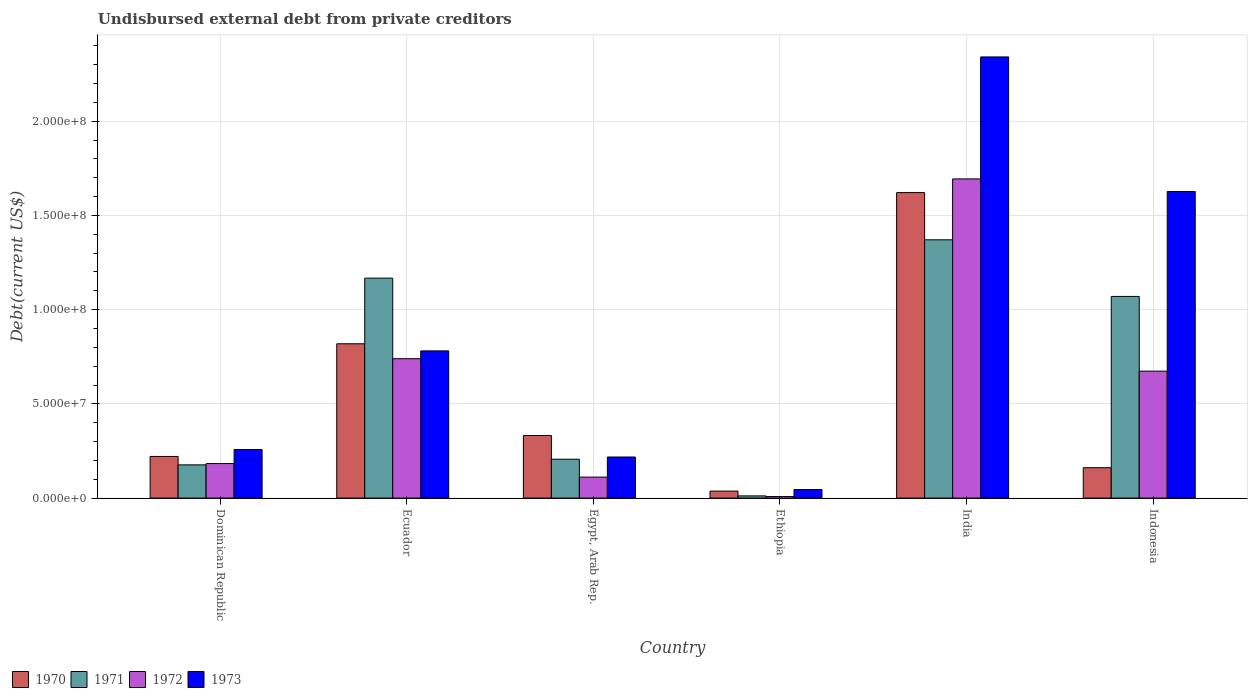What is the label of the 3rd group of bars from the left?
Give a very brief answer. Egypt, Arab Rep. In how many cases, is the number of bars for a given country not equal to the number of legend labels?
Make the answer very short. 0. What is the total debt in 1970 in Ethiopia?
Make the answer very short. 3.70e+06. Across all countries, what is the maximum total debt in 1972?
Offer a terse response. 1.69e+08. Across all countries, what is the minimum total debt in 1973?
Offer a very short reply. 4.57e+06. In which country was the total debt in 1973 maximum?
Offer a very short reply. India. In which country was the total debt in 1970 minimum?
Your response must be concise. Ethiopia. What is the total total debt in 1971 in the graph?
Give a very brief answer. 4.00e+08. What is the difference between the total debt in 1973 in Ecuador and that in Indonesia?
Offer a very short reply. -8.46e+07. What is the difference between the total debt in 1970 in Ecuador and the total debt in 1972 in Dominican Republic?
Provide a succinct answer. 6.36e+07. What is the average total debt in 1973 per country?
Your response must be concise. 8.78e+07. What is the difference between the total debt of/in 1972 and total debt of/in 1971 in Ethiopia?
Ensure brevity in your answer.  -3.45e+05. In how many countries, is the total debt in 1972 greater than 30000000 US$?
Offer a very short reply. 3. What is the ratio of the total debt in 1970 in Egypt, Arab Rep. to that in Ethiopia?
Your answer should be compact. 8.99. Is the total debt in 1973 in Egypt, Arab Rep. less than that in India?
Provide a short and direct response. Yes. Is the difference between the total debt in 1972 in Dominican Republic and Ethiopia greater than the difference between the total debt in 1971 in Dominican Republic and Ethiopia?
Provide a succinct answer. Yes. What is the difference between the highest and the second highest total debt in 1972?
Offer a terse response. 6.60e+06. What is the difference between the highest and the lowest total debt in 1973?
Ensure brevity in your answer.  2.30e+08. Is it the case that in every country, the sum of the total debt in 1970 and total debt in 1973 is greater than the sum of total debt in 1972 and total debt in 1971?
Your answer should be compact. No. What does the 2nd bar from the right in Dominican Republic represents?
Give a very brief answer. 1972. Are all the bars in the graph horizontal?
Provide a short and direct response. No. How many countries are there in the graph?
Ensure brevity in your answer.  6. Are the values on the major ticks of Y-axis written in scientific E-notation?
Offer a very short reply. Yes. How are the legend labels stacked?
Provide a succinct answer. Horizontal. What is the title of the graph?
Keep it short and to the point. Undisbursed external debt from private creditors. Does "1976" appear as one of the legend labels in the graph?
Make the answer very short. No. What is the label or title of the X-axis?
Provide a succinct answer. Country. What is the label or title of the Y-axis?
Provide a short and direct response. Debt(current US$). What is the Debt(current US$) of 1970 in Dominican Republic?
Give a very brief answer. 2.21e+07. What is the Debt(current US$) in 1971 in Dominican Republic?
Keep it short and to the point. 1.76e+07. What is the Debt(current US$) in 1972 in Dominican Republic?
Provide a short and direct response. 1.83e+07. What is the Debt(current US$) of 1973 in Dominican Republic?
Provide a short and direct response. 2.58e+07. What is the Debt(current US$) of 1970 in Ecuador?
Keep it short and to the point. 8.19e+07. What is the Debt(current US$) in 1971 in Ecuador?
Your response must be concise. 1.17e+08. What is the Debt(current US$) in 1972 in Ecuador?
Make the answer very short. 7.40e+07. What is the Debt(current US$) in 1973 in Ecuador?
Provide a short and direct response. 7.81e+07. What is the Debt(current US$) in 1970 in Egypt, Arab Rep.?
Offer a very short reply. 3.32e+07. What is the Debt(current US$) in 1971 in Egypt, Arab Rep.?
Keep it short and to the point. 2.06e+07. What is the Debt(current US$) of 1972 in Egypt, Arab Rep.?
Provide a short and direct response. 1.11e+07. What is the Debt(current US$) in 1973 in Egypt, Arab Rep.?
Your answer should be compact. 2.18e+07. What is the Debt(current US$) of 1970 in Ethiopia?
Offer a terse response. 3.70e+06. What is the Debt(current US$) in 1971 in Ethiopia?
Keep it short and to the point. 1.16e+06. What is the Debt(current US$) in 1972 in Ethiopia?
Keep it short and to the point. 8.20e+05. What is the Debt(current US$) of 1973 in Ethiopia?
Give a very brief answer. 4.57e+06. What is the Debt(current US$) of 1970 in India?
Offer a terse response. 1.62e+08. What is the Debt(current US$) in 1971 in India?
Provide a short and direct response. 1.37e+08. What is the Debt(current US$) in 1972 in India?
Make the answer very short. 1.69e+08. What is the Debt(current US$) of 1973 in India?
Your answer should be very brief. 2.34e+08. What is the Debt(current US$) of 1970 in Indonesia?
Your answer should be compact. 1.61e+07. What is the Debt(current US$) of 1971 in Indonesia?
Give a very brief answer. 1.07e+08. What is the Debt(current US$) of 1972 in Indonesia?
Your answer should be very brief. 6.74e+07. What is the Debt(current US$) in 1973 in Indonesia?
Provide a short and direct response. 1.63e+08. Across all countries, what is the maximum Debt(current US$) of 1970?
Your answer should be compact. 1.62e+08. Across all countries, what is the maximum Debt(current US$) in 1971?
Offer a very short reply. 1.37e+08. Across all countries, what is the maximum Debt(current US$) in 1972?
Make the answer very short. 1.69e+08. Across all countries, what is the maximum Debt(current US$) of 1973?
Offer a very short reply. 2.34e+08. Across all countries, what is the minimum Debt(current US$) in 1970?
Offer a very short reply. 3.70e+06. Across all countries, what is the minimum Debt(current US$) of 1971?
Your answer should be very brief. 1.16e+06. Across all countries, what is the minimum Debt(current US$) in 1972?
Your answer should be very brief. 8.20e+05. Across all countries, what is the minimum Debt(current US$) in 1973?
Give a very brief answer. 4.57e+06. What is the total Debt(current US$) of 1970 in the graph?
Offer a terse response. 3.19e+08. What is the total Debt(current US$) in 1971 in the graph?
Offer a terse response. 4.00e+08. What is the total Debt(current US$) in 1972 in the graph?
Your answer should be compact. 3.41e+08. What is the total Debt(current US$) of 1973 in the graph?
Your answer should be very brief. 5.27e+08. What is the difference between the Debt(current US$) of 1970 in Dominican Republic and that in Ecuador?
Provide a short and direct response. -5.98e+07. What is the difference between the Debt(current US$) of 1971 in Dominican Republic and that in Ecuador?
Ensure brevity in your answer.  -9.91e+07. What is the difference between the Debt(current US$) of 1972 in Dominican Republic and that in Ecuador?
Your answer should be compact. -5.57e+07. What is the difference between the Debt(current US$) of 1973 in Dominican Republic and that in Ecuador?
Your answer should be very brief. -5.23e+07. What is the difference between the Debt(current US$) of 1970 in Dominican Republic and that in Egypt, Arab Rep.?
Provide a succinct answer. -1.11e+07. What is the difference between the Debt(current US$) in 1971 in Dominican Republic and that in Egypt, Arab Rep.?
Your response must be concise. -3.00e+06. What is the difference between the Debt(current US$) of 1972 in Dominican Republic and that in Egypt, Arab Rep.?
Your response must be concise. 7.19e+06. What is the difference between the Debt(current US$) in 1973 in Dominican Republic and that in Egypt, Arab Rep.?
Your answer should be very brief. 3.97e+06. What is the difference between the Debt(current US$) in 1970 in Dominican Republic and that in Ethiopia?
Offer a terse response. 1.84e+07. What is the difference between the Debt(current US$) of 1971 in Dominican Republic and that in Ethiopia?
Make the answer very short. 1.65e+07. What is the difference between the Debt(current US$) in 1972 in Dominican Republic and that in Ethiopia?
Give a very brief answer. 1.75e+07. What is the difference between the Debt(current US$) of 1973 in Dominican Republic and that in Ethiopia?
Your answer should be compact. 2.12e+07. What is the difference between the Debt(current US$) of 1970 in Dominican Republic and that in India?
Your response must be concise. -1.40e+08. What is the difference between the Debt(current US$) of 1971 in Dominican Republic and that in India?
Offer a terse response. -1.19e+08. What is the difference between the Debt(current US$) of 1972 in Dominican Republic and that in India?
Offer a very short reply. -1.51e+08. What is the difference between the Debt(current US$) in 1973 in Dominican Republic and that in India?
Provide a succinct answer. -2.08e+08. What is the difference between the Debt(current US$) of 1970 in Dominican Republic and that in Indonesia?
Your answer should be very brief. 5.97e+06. What is the difference between the Debt(current US$) in 1971 in Dominican Republic and that in Indonesia?
Ensure brevity in your answer.  -8.94e+07. What is the difference between the Debt(current US$) in 1972 in Dominican Republic and that in Indonesia?
Ensure brevity in your answer.  -4.91e+07. What is the difference between the Debt(current US$) in 1973 in Dominican Republic and that in Indonesia?
Your answer should be very brief. -1.37e+08. What is the difference between the Debt(current US$) of 1970 in Ecuador and that in Egypt, Arab Rep.?
Ensure brevity in your answer.  4.87e+07. What is the difference between the Debt(current US$) in 1971 in Ecuador and that in Egypt, Arab Rep.?
Ensure brevity in your answer.  9.61e+07. What is the difference between the Debt(current US$) in 1972 in Ecuador and that in Egypt, Arab Rep.?
Give a very brief answer. 6.28e+07. What is the difference between the Debt(current US$) of 1973 in Ecuador and that in Egypt, Arab Rep.?
Provide a short and direct response. 5.63e+07. What is the difference between the Debt(current US$) of 1970 in Ecuador and that in Ethiopia?
Keep it short and to the point. 7.82e+07. What is the difference between the Debt(current US$) in 1971 in Ecuador and that in Ethiopia?
Keep it short and to the point. 1.16e+08. What is the difference between the Debt(current US$) in 1972 in Ecuador and that in Ethiopia?
Ensure brevity in your answer.  7.32e+07. What is the difference between the Debt(current US$) in 1973 in Ecuador and that in Ethiopia?
Your answer should be compact. 7.35e+07. What is the difference between the Debt(current US$) in 1970 in Ecuador and that in India?
Provide a short and direct response. -8.02e+07. What is the difference between the Debt(current US$) in 1971 in Ecuador and that in India?
Offer a terse response. -2.03e+07. What is the difference between the Debt(current US$) of 1972 in Ecuador and that in India?
Ensure brevity in your answer.  -9.54e+07. What is the difference between the Debt(current US$) of 1973 in Ecuador and that in India?
Provide a succinct answer. -1.56e+08. What is the difference between the Debt(current US$) of 1970 in Ecuador and that in Indonesia?
Your response must be concise. 6.58e+07. What is the difference between the Debt(current US$) in 1971 in Ecuador and that in Indonesia?
Ensure brevity in your answer.  9.70e+06. What is the difference between the Debt(current US$) in 1972 in Ecuador and that in Indonesia?
Provide a succinct answer. 6.60e+06. What is the difference between the Debt(current US$) of 1973 in Ecuador and that in Indonesia?
Ensure brevity in your answer.  -8.46e+07. What is the difference between the Debt(current US$) of 1970 in Egypt, Arab Rep. and that in Ethiopia?
Your response must be concise. 2.95e+07. What is the difference between the Debt(current US$) in 1971 in Egypt, Arab Rep. and that in Ethiopia?
Offer a very short reply. 1.95e+07. What is the difference between the Debt(current US$) of 1972 in Egypt, Arab Rep. and that in Ethiopia?
Your answer should be compact. 1.03e+07. What is the difference between the Debt(current US$) in 1973 in Egypt, Arab Rep. and that in Ethiopia?
Make the answer very short. 1.72e+07. What is the difference between the Debt(current US$) of 1970 in Egypt, Arab Rep. and that in India?
Make the answer very short. -1.29e+08. What is the difference between the Debt(current US$) of 1971 in Egypt, Arab Rep. and that in India?
Your response must be concise. -1.16e+08. What is the difference between the Debt(current US$) of 1972 in Egypt, Arab Rep. and that in India?
Provide a short and direct response. -1.58e+08. What is the difference between the Debt(current US$) of 1973 in Egypt, Arab Rep. and that in India?
Your response must be concise. -2.12e+08. What is the difference between the Debt(current US$) in 1970 in Egypt, Arab Rep. and that in Indonesia?
Provide a short and direct response. 1.71e+07. What is the difference between the Debt(current US$) in 1971 in Egypt, Arab Rep. and that in Indonesia?
Provide a succinct answer. -8.64e+07. What is the difference between the Debt(current US$) of 1972 in Egypt, Arab Rep. and that in Indonesia?
Offer a terse response. -5.62e+07. What is the difference between the Debt(current US$) of 1973 in Egypt, Arab Rep. and that in Indonesia?
Provide a succinct answer. -1.41e+08. What is the difference between the Debt(current US$) of 1970 in Ethiopia and that in India?
Offer a terse response. -1.58e+08. What is the difference between the Debt(current US$) of 1971 in Ethiopia and that in India?
Give a very brief answer. -1.36e+08. What is the difference between the Debt(current US$) of 1972 in Ethiopia and that in India?
Provide a succinct answer. -1.69e+08. What is the difference between the Debt(current US$) in 1973 in Ethiopia and that in India?
Ensure brevity in your answer.  -2.30e+08. What is the difference between the Debt(current US$) of 1970 in Ethiopia and that in Indonesia?
Provide a short and direct response. -1.24e+07. What is the difference between the Debt(current US$) of 1971 in Ethiopia and that in Indonesia?
Give a very brief answer. -1.06e+08. What is the difference between the Debt(current US$) in 1972 in Ethiopia and that in Indonesia?
Offer a terse response. -6.66e+07. What is the difference between the Debt(current US$) in 1973 in Ethiopia and that in Indonesia?
Ensure brevity in your answer.  -1.58e+08. What is the difference between the Debt(current US$) of 1970 in India and that in Indonesia?
Provide a short and direct response. 1.46e+08. What is the difference between the Debt(current US$) in 1971 in India and that in Indonesia?
Offer a very short reply. 3.00e+07. What is the difference between the Debt(current US$) of 1972 in India and that in Indonesia?
Provide a short and direct response. 1.02e+08. What is the difference between the Debt(current US$) in 1973 in India and that in Indonesia?
Provide a short and direct response. 7.14e+07. What is the difference between the Debt(current US$) in 1970 in Dominican Republic and the Debt(current US$) in 1971 in Ecuador?
Provide a succinct answer. -9.46e+07. What is the difference between the Debt(current US$) of 1970 in Dominican Republic and the Debt(current US$) of 1972 in Ecuador?
Offer a terse response. -5.19e+07. What is the difference between the Debt(current US$) in 1970 in Dominican Republic and the Debt(current US$) in 1973 in Ecuador?
Your response must be concise. -5.60e+07. What is the difference between the Debt(current US$) of 1971 in Dominican Republic and the Debt(current US$) of 1972 in Ecuador?
Keep it short and to the point. -5.63e+07. What is the difference between the Debt(current US$) in 1971 in Dominican Republic and the Debt(current US$) in 1973 in Ecuador?
Ensure brevity in your answer.  -6.05e+07. What is the difference between the Debt(current US$) of 1972 in Dominican Republic and the Debt(current US$) of 1973 in Ecuador?
Your answer should be compact. -5.98e+07. What is the difference between the Debt(current US$) in 1970 in Dominican Republic and the Debt(current US$) in 1971 in Egypt, Arab Rep.?
Provide a succinct answer. 1.46e+06. What is the difference between the Debt(current US$) of 1970 in Dominican Republic and the Debt(current US$) of 1972 in Egypt, Arab Rep.?
Provide a short and direct response. 1.10e+07. What is the difference between the Debt(current US$) in 1970 in Dominican Republic and the Debt(current US$) in 1973 in Egypt, Arab Rep.?
Your answer should be compact. 2.96e+05. What is the difference between the Debt(current US$) in 1971 in Dominican Republic and the Debt(current US$) in 1972 in Egypt, Arab Rep.?
Offer a very short reply. 6.50e+06. What is the difference between the Debt(current US$) of 1971 in Dominican Republic and the Debt(current US$) of 1973 in Egypt, Arab Rep.?
Give a very brief answer. -4.17e+06. What is the difference between the Debt(current US$) in 1972 in Dominican Republic and the Debt(current US$) in 1973 in Egypt, Arab Rep.?
Keep it short and to the point. -3.48e+06. What is the difference between the Debt(current US$) of 1970 in Dominican Republic and the Debt(current US$) of 1971 in Ethiopia?
Offer a terse response. 2.09e+07. What is the difference between the Debt(current US$) of 1970 in Dominican Republic and the Debt(current US$) of 1972 in Ethiopia?
Make the answer very short. 2.13e+07. What is the difference between the Debt(current US$) of 1970 in Dominican Republic and the Debt(current US$) of 1973 in Ethiopia?
Provide a succinct answer. 1.75e+07. What is the difference between the Debt(current US$) in 1971 in Dominican Republic and the Debt(current US$) in 1972 in Ethiopia?
Your response must be concise. 1.68e+07. What is the difference between the Debt(current US$) of 1971 in Dominican Republic and the Debt(current US$) of 1973 in Ethiopia?
Your answer should be compact. 1.31e+07. What is the difference between the Debt(current US$) in 1972 in Dominican Republic and the Debt(current US$) in 1973 in Ethiopia?
Your response must be concise. 1.37e+07. What is the difference between the Debt(current US$) of 1970 in Dominican Republic and the Debt(current US$) of 1971 in India?
Offer a very short reply. -1.15e+08. What is the difference between the Debt(current US$) of 1970 in Dominican Republic and the Debt(current US$) of 1972 in India?
Provide a short and direct response. -1.47e+08. What is the difference between the Debt(current US$) of 1970 in Dominican Republic and the Debt(current US$) of 1973 in India?
Your answer should be compact. -2.12e+08. What is the difference between the Debt(current US$) of 1971 in Dominican Republic and the Debt(current US$) of 1972 in India?
Ensure brevity in your answer.  -1.52e+08. What is the difference between the Debt(current US$) of 1971 in Dominican Republic and the Debt(current US$) of 1973 in India?
Provide a succinct answer. -2.16e+08. What is the difference between the Debt(current US$) in 1972 in Dominican Republic and the Debt(current US$) in 1973 in India?
Your response must be concise. -2.16e+08. What is the difference between the Debt(current US$) of 1970 in Dominican Republic and the Debt(current US$) of 1971 in Indonesia?
Provide a succinct answer. -8.49e+07. What is the difference between the Debt(current US$) in 1970 in Dominican Republic and the Debt(current US$) in 1972 in Indonesia?
Give a very brief answer. -4.53e+07. What is the difference between the Debt(current US$) of 1970 in Dominican Republic and the Debt(current US$) of 1973 in Indonesia?
Your answer should be compact. -1.41e+08. What is the difference between the Debt(current US$) of 1971 in Dominican Republic and the Debt(current US$) of 1972 in Indonesia?
Provide a succinct answer. -4.97e+07. What is the difference between the Debt(current US$) of 1971 in Dominican Republic and the Debt(current US$) of 1973 in Indonesia?
Provide a succinct answer. -1.45e+08. What is the difference between the Debt(current US$) of 1972 in Dominican Republic and the Debt(current US$) of 1973 in Indonesia?
Offer a very short reply. -1.44e+08. What is the difference between the Debt(current US$) of 1970 in Ecuador and the Debt(current US$) of 1971 in Egypt, Arab Rep.?
Offer a terse response. 6.13e+07. What is the difference between the Debt(current US$) of 1970 in Ecuador and the Debt(current US$) of 1972 in Egypt, Arab Rep.?
Your answer should be very brief. 7.08e+07. What is the difference between the Debt(current US$) of 1970 in Ecuador and the Debt(current US$) of 1973 in Egypt, Arab Rep.?
Your answer should be compact. 6.01e+07. What is the difference between the Debt(current US$) in 1971 in Ecuador and the Debt(current US$) in 1972 in Egypt, Arab Rep.?
Ensure brevity in your answer.  1.06e+08. What is the difference between the Debt(current US$) of 1971 in Ecuador and the Debt(current US$) of 1973 in Egypt, Arab Rep.?
Offer a very short reply. 9.49e+07. What is the difference between the Debt(current US$) in 1972 in Ecuador and the Debt(current US$) in 1973 in Egypt, Arab Rep.?
Ensure brevity in your answer.  5.22e+07. What is the difference between the Debt(current US$) of 1970 in Ecuador and the Debt(current US$) of 1971 in Ethiopia?
Your answer should be very brief. 8.07e+07. What is the difference between the Debt(current US$) of 1970 in Ecuador and the Debt(current US$) of 1972 in Ethiopia?
Your answer should be very brief. 8.11e+07. What is the difference between the Debt(current US$) in 1970 in Ecuador and the Debt(current US$) in 1973 in Ethiopia?
Make the answer very short. 7.73e+07. What is the difference between the Debt(current US$) of 1971 in Ecuador and the Debt(current US$) of 1972 in Ethiopia?
Give a very brief answer. 1.16e+08. What is the difference between the Debt(current US$) in 1971 in Ecuador and the Debt(current US$) in 1973 in Ethiopia?
Offer a very short reply. 1.12e+08. What is the difference between the Debt(current US$) in 1972 in Ecuador and the Debt(current US$) in 1973 in Ethiopia?
Offer a terse response. 6.94e+07. What is the difference between the Debt(current US$) of 1970 in Ecuador and the Debt(current US$) of 1971 in India?
Provide a succinct answer. -5.52e+07. What is the difference between the Debt(current US$) in 1970 in Ecuador and the Debt(current US$) in 1972 in India?
Your answer should be compact. -8.75e+07. What is the difference between the Debt(current US$) in 1970 in Ecuador and the Debt(current US$) in 1973 in India?
Give a very brief answer. -1.52e+08. What is the difference between the Debt(current US$) of 1971 in Ecuador and the Debt(current US$) of 1972 in India?
Your answer should be compact. -5.27e+07. What is the difference between the Debt(current US$) of 1971 in Ecuador and the Debt(current US$) of 1973 in India?
Your response must be concise. -1.17e+08. What is the difference between the Debt(current US$) of 1972 in Ecuador and the Debt(current US$) of 1973 in India?
Offer a very short reply. -1.60e+08. What is the difference between the Debt(current US$) of 1970 in Ecuador and the Debt(current US$) of 1971 in Indonesia?
Keep it short and to the point. -2.51e+07. What is the difference between the Debt(current US$) of 1970 in Ecuador and the Debt(current US$) of 1972 in Indonesia?
Provide a succinct answer. 1.45e+07. What is the difference between the Debt(current US$) in 1970 in Ecuador and the Debt(current US$) in 1973 in Indonesia?
Offer a terse response. -8.08e+07. What is the difference between the Debt(current US$) in 1971 in Ecuador and the Debt(current US$) in 1972 in Indonesia?
Provide a succinct answer. 4.93e+07. What is the difference between the Debt(current US$) of 1971 in Ecuador and the Debt(current US$) of 1973 in Indonesia?
Ensure brevity in your answer.  -4.60e+07. What is the difference between the Debt(current US$) in 1972 in Ecuador and the Debt(current US$) in 1973 in Indonesia?
Offer a terse response. -8.87e+07. What is the difference between the Debt(current US$) of 1970 in Egypt, Arab Rep. and the Debt(current US$) of 1971 in Ethiopia?
Make the answer very short. 3.21e+07. What is the difference between the Debt(current US$) of 1970 in Egypt, Arab Rep. and the Debt(current US$) of 1972 in Ethiopia?
Provide a short and direct response. 3.24e+07. What is the difference between the Debt(current US$) in 1970 in Egypt, Arab Rep. and the Debt(current US$) in 1973 in Ethiopia?
Your answer should be very brief. 2.87e+07. What is the difference between the Debt(current US$) of 1971 in Egypt, Arab Rep. and the Debt(current US$) of 1972 in Ethiopia?
Make the answer very short. 1.98e+07. What is the difference between the Debt(current US$) of 1971 in Egypt, Arab Rep. and the Debt(current US$) of 1973 in Ethiopia?
Offer a very short reply. 1.61e+07. What is the difference between the Debt(current US$) of 1972 in Egypt, Arab Rep. and the Debt(current US$) of 1973 in Ethiopia?
Ensure brevity in your answer.  6.56e+06. What is the difference between the Debt(current US$) of 1970 in Egypt, Arab Rep. and the Debt(current US$) of 1971 in India?
Provide a short and direct response. -1.04e+08. What is the difference between the Debt(current US$) in 1970 in Egypt, Arab Rep. and the Debt(current US$) in 1972 in India?
Offer a very short reply. -1.36e+08. What is the difference between the Debt(current US$) in 1970 in Egypt, Arab Rep. and the Debt(current US$) in 1973 in India?
Ensure brevity in your answer.  -2.01e+08. What is the difference between the Debt(current US$) of 1971 in Egypt, Arab Rep. and the Debt(current US$) of 1972 in India?
Keep it short and to the point. -1.49e+08. What is the difference between the Debt(current US$) of 1971 in Egypt, Arab Rep. and the Debt(current US$) of 1973 in India?
Offer a terse response. -2.13e+08. What is the difference between the Debt(current US$) of 1972 in Egypt, Arab Rep. and the Debt(current US$) of 1973 in India?
Offer a terse response. -2.23e+08. What is the difference between the Debt(current US$) in 1970 in Egypt, Arab Rep. and the Debt(current US$) in 1971 in Indonesia?
Provide a succinct answer. -7.38e+07. What is the difference between the Debt(current US$) in 1970 in Egypt, Arab Rep. and the Debt(current US$) in 1972 in Indonesia?
Your response must be concise. -3.42e+07. What is the difference between the Debt(current US$) of 1970 in Egypt, Arab Rep. and the Debt(current US$) of 1973 in Indonesia?
Offer a very short reply. -1.29e+08. What is the difference between the Debt(current US$) of 1971 in Egypt, Arab Rep. and the Debt(current US$) of 1972 in Indonesia?
Your answer should be compact. -4.67e+07. What is the difference between the Debt(current US$) of 1971 in Egypt, Arab Rep. and the Debt(current US$) of 1973 in Indonesia?
Ensure brevity in your answer.  -1.42e+08. What is the difference between the Debt(current US$) in 1972 in Egypt, Arab Rep. and the Debt(current US$) in 1973 in Indonesia?
Keep it short and to the point. -1.52e+08. What is the difference between the Debt(current US$) of 1970 in Ethiopia and the Debt(current US$) of 1971 in India?
Make the answer very short. -1.33e+08. What is the difference between the Debt(current US$) of 1970 in Ethiopia and the Debt(current US$) of 1972 in India?
Provide a short and direct response. -1.66e+08. What is the difference between the Debt(current US$) in 1970 in Ethiopia and the Debt(current US$) in 1973 in India?
Offer a terse response. -2.30e+08. What is the difference between the Debt(current US$) of 1971 in Ethiopia and the Debt(current US$) of 1972 in India?
Give a very brief answer. -1.68e+08. What is the difference between the Debt(current US$) in 1971 in Ethiopia and the Debt(current US$) in 1973 in India?
Provide a short and direct response. -2.33e+08. What is the difference between the Debt(current US$) in 1972 in Ethiopia and the Debt(current US$) in 1973 in India?
Offer a terse response. -2.33e+08. What is the difference between the Debt(current US$) of 1970 in Ethiopia and the Debt(current US$) of 1971 in Indonesia?
Provide a succinct answer. -1.03e+08. What is the difference between the Debt(current US$) in 1970 in Ethiopia and the Debt(current US$) in 1972 in Indonesia?
Make the answer very short. -6.37e+07. What is the difference between the Debt(current US$) in 1970 in Ethiopia and the Debt(current US$) in 1973 in Indonesia?
Provide a succinct answer. -1.59e+08. What is the difference between the Debt(current US$) in 1971 in Ethiopia and the Debt(current US$) in 1972 in Indonesia?
Provide a short and direct response. -6.62e+07. What is the difference between the Debt(current US$) of 1971 in Ethiopia and the Debt(current US$) of 1973 in Indonesia?
Offer a terse response. -1.62e+08. What is the difference between the Debt(current US$) in 1972 in Ethiopia and the Debt(current US$) in 1973 in Indonesia?
Give a very brief answer. -1.62e+08. What is the difference between the Debt(current US$) in 1970 in India and the Debt(current US$) in 1971 in Indonesia?
Your answer should be very brief. 5.51e+07. What is the difference between the Debt(current US$) of 1970 in India and the Debt(current US$) of 1972 in Indonesia?
Provide a succinct answer. 9.47e+07. What is the difference between the Debt(current US$) of 1970 in India and the Debt(current US$) of 1973 in Indonesia?
Provide a short and direct response. -5.84e+05. What is the difference between the Debt(current US$) of 1971 in India and the Debt(current US$) of 1972 in Indonesia?
Offer a very short reply. 6.97e+07. What is the difference between the Debt(current US$) in 1971 in India and the Debt(current US$) in 1973 in Indonesia?
Your response must be concise. -2.56e+07. What is the difference between the Debt(current US$) of 1972 in India and the Debt(current US$) of 1973 in Indonesia?
Your response must be concise. 6.68e+06. What is the average Debt(current US$) in 1970 per country?
Provide a short and direct response. 5.32e+07. What is the average Debt(current US$) in 1971 per country?
Ensure brevity in your answer.  6.67e+07. What is the average Debt(current US$) of 1972 per country?
Your response must be concise. 5.68e+07. What is the average Debt(current US$) in 1973 per country?
Your response must be concise. 8.78e+07. What is the difference between the Debt(current US$) in 1970 and Debt(current US$) in 1971 in Dominican Republic?
Make the answer very short. 4.46e+06. What is the difference between the Debt(current US$) in 1970 and Debt(current US$) in 1972 in Dominican Republic?
Make the answer very short. 3.78e+06. What is the difference between the Debt(current US$) of 1970 and Debt(current US$) of 1973 in Dominican Republic?
Your answer should be compact. -3.68e+06. What is the difference between the Debt(current US$) in 1971 and Debt(current US$) in 1972 in Dominican Republic?
Offer a very short reply. -6.84e+05. What is the difference between the Debt(current US$) of 1971 and Debt(current US$) of 1973 in Dominican Republic?
Offer a terse response. -8.14e+06. What is the difference between the Debt(current US$) of 1972 and Debt(current US$) of 1973 in Dominican Republic?
Make the answer very short. -7.46e+06. What is the difference between the Debt(current US$) of 1970 and Debt(current US$) of 1971 in Ecuador?
Give a very brief answer. -3.48e+07. What is the difference between the Debt(current US$) in 1970 and Debt(current US$) in 1972 in Ecuador?
Offer a very short reply. 7.92e+06. What is the difference between the Debt(current US$) in 1970 and Debt(current US$) in 1973 in Ecuador?
Your answer should be very brief. 3.78e+06. What is the difference between the Debt(current US$) in 1971 and Debt(current US$) in 1972 in Ecuador?
Your answer should be very brief. 4.27e+07. What is the difference between the Debt(current US$) of 1971 and Debt(current US$) of 1973 in Ecuador?
Provide a short and direct response. 3.86e+07. What is the difference between the Debt(current US$) of 1972 and Debt(current US$) of 1973 in Ecuador?
Make the answer very short. -4.14e+06. What is the difference between the Debt(current US$) of 1970 and Debt(current US$) of 1971 in Egypt, Arab Rep.?
Offer a terse response. 1.26e+07. What is the difference between the Debt(current US$) in 1970 and Debt(current US$) in 1972 in Egypt, Arab Rep.?
Keep it short and to the point. 2.21e+07. What is the difference between the Debt(current US$) in 1970 and Debt(current US$) in 1973 in Egypt, Arab Rep.?
Offer a very short reply. 1.14e+07. What is the difference between the Debt(current US$) of 1971 and Debt(current US$) of 1972 in Egypt, Arab Rep.?
Your answer should be compact. 9.50e+06. What is the difference between the Debt(current US$) in 1971 and Debt(current US$) in 1973 in Egypt, Arab Rep.?
Offer a very short reply. -1.17e+06. What is the difference between the Debt(current US$) of 1972 and Debt(current US$) of 1973 in Egypt, Arab Rep.?
Ensure brevity in your answer.  -1.07e+07. What is the difference between the Debt(current US$) in 1970 and Debt(current US$) in 1971 in Ethiopia?
Provide a short and direct response. 2.53e+06. What is the difference between the Debt(current US$) of 1970 and Debt(current US$) of 1972 in Ethiopia?
Your answer should be very brief. 2.88e+06. What is the difference between the Debt(current US$) of 1970 and Debt(current US$) of 1973 in Ethiopia?
Provide a succinct answer. -8.70e+05. What is the difference between the Debt(current US$) of 1971 and Debt(current US$) of 1972 in Ethiopia?
Provide a short and direct response. 3.45e+05. What is the difference between the Debt(current US$) of 1971 and Debt(current US$) of 1973 in Ethiopia?
Give a very brief answer. -3.40e+06. What is the difference between the Debt(current US$) in 1972 and Debt(current US$) in 1973 in Ethiopia?
Give a very brief answer. -3.75e+06. What is the difference between the Debt(current US$) of 1970 and Debt(current US$) of 1971 in India?
Provide a succinct answer. 2.51e+07. What is the difference between the Debt(current US$) of 1970 and Debt(current US$) of 1972 in India?
Your answer should be compact. -7.26e+06. What is the difference between the Debt(current US$) of 1970 and Debt(current US$) of 1973 in India?
Ensure brevity in your answer.  -7.20e+07. What is the difference between the Debt(current US$) of 1971 and Debt(current US$) of 1972 in India?
Keep it short and to the point. -3.23e+07. What is the difference between the Debt(current US$) of 1971 and Debt(current US$) of 1973 in India?
Your answer should be very brief. -9.70e+07. What is the difference between the Debt(current US$) of 1972 and Debt(current US$) of 1973 in India?
Give a very brief answer. -6.47e+07. What is the difference between the Debt(current US$) in 1970 and Debt(current US$) in 1971 in Indonesia?
Offer a terse response. -9.09e+07. What is the difference between the Debt(current US$) of 1970 and Debt(current US$) of 1972 in Indonesia?
Offer a terse response. -5.12e+07. What is the difference between the Debt(current US$) of 1970 and Debt(current US$) of 1973 in Indonesia?
Your answer should be very brief. -1.47e+08. What is the difference between the Debt(current US$) of 1971 and Debt(current US$) of 1972 in Indonesia?
Your response must be concise. 3.96e+07. What is the difference between the Debt(current US$) in 1971 and Debt(current US$) in 1973 in Indonesia?
Provide a succinct answer. -5.57e+07. What is the difference between the Debt(current US$) of 1972 and Debt(current US$) of 1973 in Indonesia?
Your answer should be very brief. -9.53e+07. What is the ratio of the Debt(current US$) in 1970 in Dominican Republic to that in Ecuador?
Your answer should be compact. 0.27. What is the ratio of the Debt(current US$) in 1971 in Dominican Republic to that in Ecuador?
Provide a succinct answer. 0.15. What is the ratio of the Debt(current US$) of 1972 in Dominican Republic to that in Ecuador?
Offer a terse response. 0.25. What is the ratio of the Debt(current US$) in 1973 in Dominican Republic to that in Ecuador?
Provide a short and direct response. 0.33. What is the ratio of the Debt(current US$) of 1970 in Dominican Republic to that in Egypt, Arab Rep.?
Offer a very short reply. 0.67. What is the ratio of the Debt(current US$) in 1971 in Dominican Republic to that in Egypt, Arab Rep.?
Your response must be concise. 0.85. What is the ratio of the Debt(current US$) in 1972 in Dominican Republic to that in Egypt, Arab Rep.?
Keep it short and to the point. 1.65. What is the ratio of the Debt(current US$) of 1973 in Dominican Republic to that in Egypt, Arab Rep.?
Ensure brevity in your answer.  1.18. What is the ratio of the Debt(current US$) in 1970 in Dominican Republic to that in Ethiopia?
Offer a terse response. 5.98. What is the ratio of the Debt(current US$) in 1971 in Dominican Republic to that in Ethiopia?
Your answer should be compact. 15.13. What is the ratio of the Debt(current US$) in 1972 in Dominican Republic to that in Ethiopia?
Provide a succinct answer. 22.34. What is the ratio of the Debt(current US$) in 1973 in Dominican Republic to that in Ethiopia?
Give a very brief answer. 5.64. What is the ratio of the Debt(current US$) of 1970 in Dominican Republic to that in India?
Keep it short and to the point. 0.14. What is the ratio of the Debt(current US$) of 1971 in Dominican Republic to that in India?
Offer a very short reply. 0.13. What is the ratio of the Debt(current US$) in 1972 in Dominican Republic to that in India?
Your answer should be compact. 0.11. What is the ratio of the Debt(current US$) of 1973 in Dominican Republic to that in India?
Offer a very short reply. 0.11. What is the ratio of the Debt(current US$) in 1970 in Dominican Republic to that in Indonesia?
Provide a short and direct response. 1.37. What is the ratio of the Debt(current US$) in 1971 in Dominican Republic to that in Indonesia?
Provide a succinct answer. 0.16. What is the ratio of the Debt(current US$) of 1972 in Dominican Republic to that in Indonesia?
Your answer should be very brief. 0.27. What is the ratio of the Debt(current US$) in 1973 in Dominican Republic to that in Indonesia?
Make the answer very short. 0.16. What is the ratio of the Debt(current US$) of 1970 in Ecuador to that in Egypt, Arab Rep.?
Provide a succinct answer. 2.47. What is the ratio of the Debt(current US$) of 1971 in Ecuador to that in Egypt, Arab Rep.?
Your answer should be compact. 5.66. What is the ratio of the Debt(current US$) in 1972 in Ecuador to that in Egypt, Arab Rep.?
Give a very brief answer. 6.65. What is the ratio of the Debt(current US$) in 1973 in Ecuador to that in Egypt, Arab Rep.?
Provide a succinct answer. 3.58. What is the ratio of the Debt(current US$) in 1970 in Ecuador to that in Ethiopia?
Ensure brevity in your answer.  22.15. What is the ratio of the Debt(current US$) in 1971 in Ecuador to that in Ethiopia?
Provide a succinct answer. 100.19. What is the ratio of the Debt(current US$) of 1972 in Ecuador to that in Ethiopia?
Ensure brevity in your answer.  90.21. What is the ratio of the Debt(current US$) in 1973 in Ecuador to that in Ethiopia?
Keep it short and to the point. 17.1. What is the ratio of the Debt(current US$) in 1970 in Ecuador to that in India?
Keep it short and to the point. 0.51. What is the ratio of the Debt(current US$) in 1971 in Ecuador to that in India?
Provide a succinct answer. 0.85. What is the ratio of the Debt(current US$) of 1972 in Ecuador to that in India?
Give a very brief answer. 0.44. What is the ratio of the Debt(current US$) in 1973 in Ecuador to that in India?
Make the answer very short. 0.33. What is the ratio of the Debt(current US$) in 1970 in Ecuador to that in Indonesia?
Keep it short and to the point. 5.08. What is the ratio of the Debt(current US$) in 1971 in Ecuador to that in Indonesia?
Give a very brief answer. 1.09. What is the ratio of the Debt(current US$) of 1972 in Ecuador to that in Indonesia?
Your response must be concise. 1.1. What is the ratio of the Debt(current US$) in 1973 in Ecuador to that in Indonesia?
Provide a short and direct response. 0.48. What is the ratio of the Debt(current US$) of 1970 in Egypt, Arab Rep. to that in Ethiopia?
Ensure brevity in your answer.  8.99. What is the ratio of the Debt(current US$) in 1971 in Egypt, Arab Rep. to that in Ethiopia?
Keep it short and to the point. 17.71. What is the ratio of the Debt(current US$) in 1972 in Egypt, Arab Rep. to that in Ethiopia?
Provide a succinct answer. 13.57. What is the ratio of the Debt(current US$) in 1973 in Egypt, Arab Rep. to that in Ethiopia?
Make the answer very short. 4.77. What is the ratio of the Debt(current US$) of 1970 in Egypt, Arab Rep. to that in India?
Ensure brevity in your answer.  0.2. What is the ratio of the Debt(current US$) of 1971 in Egypt, Arab Rep. to that in India?
Offer a terse response. 0.15. What is the ratio of the Debt(current US$) of 1972 in Egypt, Arab Rep. to that in India?
Your answer should be compact. 0.07. What is the ratio of the Debt(current US$) of 1973 in Egypt, Arab Rep. to that in India?
Give a very brief answer. 0.09. What is the ratio of the Debt(current US$) in 1970 in Egypt, Arab Rep. to that in Indonesia?
Make the answer very short. 2.06. What is the ratio of the Debt(current US$) in 1971 in Egypt, Arab Rep. to that in Indonesia?
Provide a succinct answer. 0.19. What is the ratio of the Debt(current US$) of 1972 in Egypt, Arab Rep. to that in Indonesia?
Ensure brevity in your answer.  0.17. What is the ratio of the Debt(current US$) in 1973 in Egypt, Arab Rep. to that in Indonesia?
Offer a very short reply. 0.13. What is the ratio of the Debt(current US$) of 1970 in Ethiopia to that in India?
Keep it short and to the point. 0.02. What is the ratio of the Debt(current US$) of 1971 in Ethiopia to that in India?
Provide a succinct answer. 0.01. What is the ratio of the Debt(current US$) in 1972 in Ethiopia to that in India?
Ensure brevity in your answer.  0. What is the ratio of the Debt(current US$) of 1973 in Ethiopia to that in India?
Provide a short and direct response. 0.02. What is the ratio of the Debt(current US$) in 1970 in Ethiopia to that in Indonesia?
Your response must be concise. 0.23. What is the ratio of the Debt(current US$) in 1971 in Ethiopia to that in Indonesia?
Keep it short and to the point. 0.01. What is the ratio of the Debt(current US$) of 1972 in Ethiopia to that in Indonesia?
Provide a short and direct response. 0.01. What is the ratio of the Debt(current US$) of 1973 in Ethiopia to that in Indonesia?
Provide a short and direct response. 0.03. What is the ratio of the Debt(current US$) of 1970 in India to that in Indonesia?
Provide a succinct answer. 10.05. What is the ratio of the Debt(current US$) in 1971 in India to that in Indonesia?
Provide a succinct answer. 1.28. What is the ratio of the Debt(current US$) of 1972 in India to that in Indonesia?
Ensure brevity in your answer.  2.51. What is the ratio of the Debt(current US$) of 1973 in India to that in Indonesia?
Provide a succinct answer. 1.44. What is the difference between the highest and the second highest Debt(current US$) of 1970?
Ensure brevity in your answer.  8.02e+07. What is the difference between the highest and the second highest Debt(current US$) in 1971?
Your response must be concise. 2.03e+07. What is the difference between the highest and the second highest Debt(current US$) of 1972?
Ensure brevity in your answer.  9.54e+07. What is the difference between the highest and the second highest Debt(current US$) of 1973?
Your answer should be very brief. 7.14e+07. What is the difference between the highest and the lowest Debt(current US$) in 1970?
Provide a short and direct response. 1.58e+08. What is the difference between the highest and the lowest Debt(current US$) in 1971?
Provide a short and direct response. 1.36e+08. What is the difference between the highest and the lowest Debt(current US$) of 1972?
Provide a succinct answer. 1.69e+08. What is the difference between the highest and the lowest Debt(current US$) in 1973?
Offer a very short reply. 2.30e+08. 